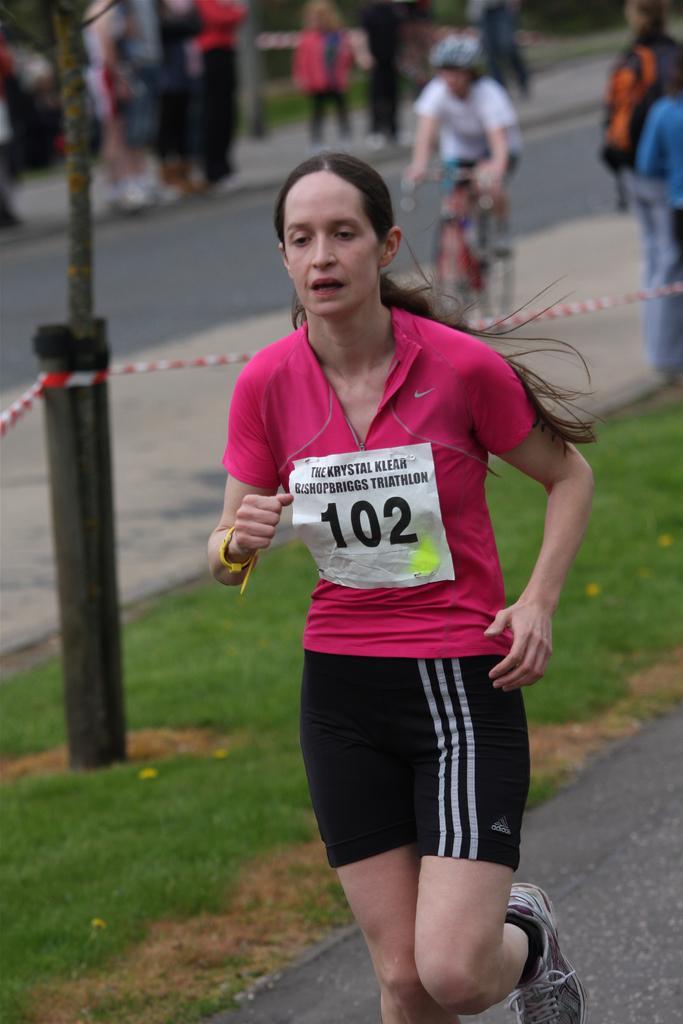Could you give a brief overview of what you see in this image? In this image we can see a woman running on the road. We can also see some grass, a rope tied to a pole and a person riding bicycle. On the backside we can see a group of people standing. 